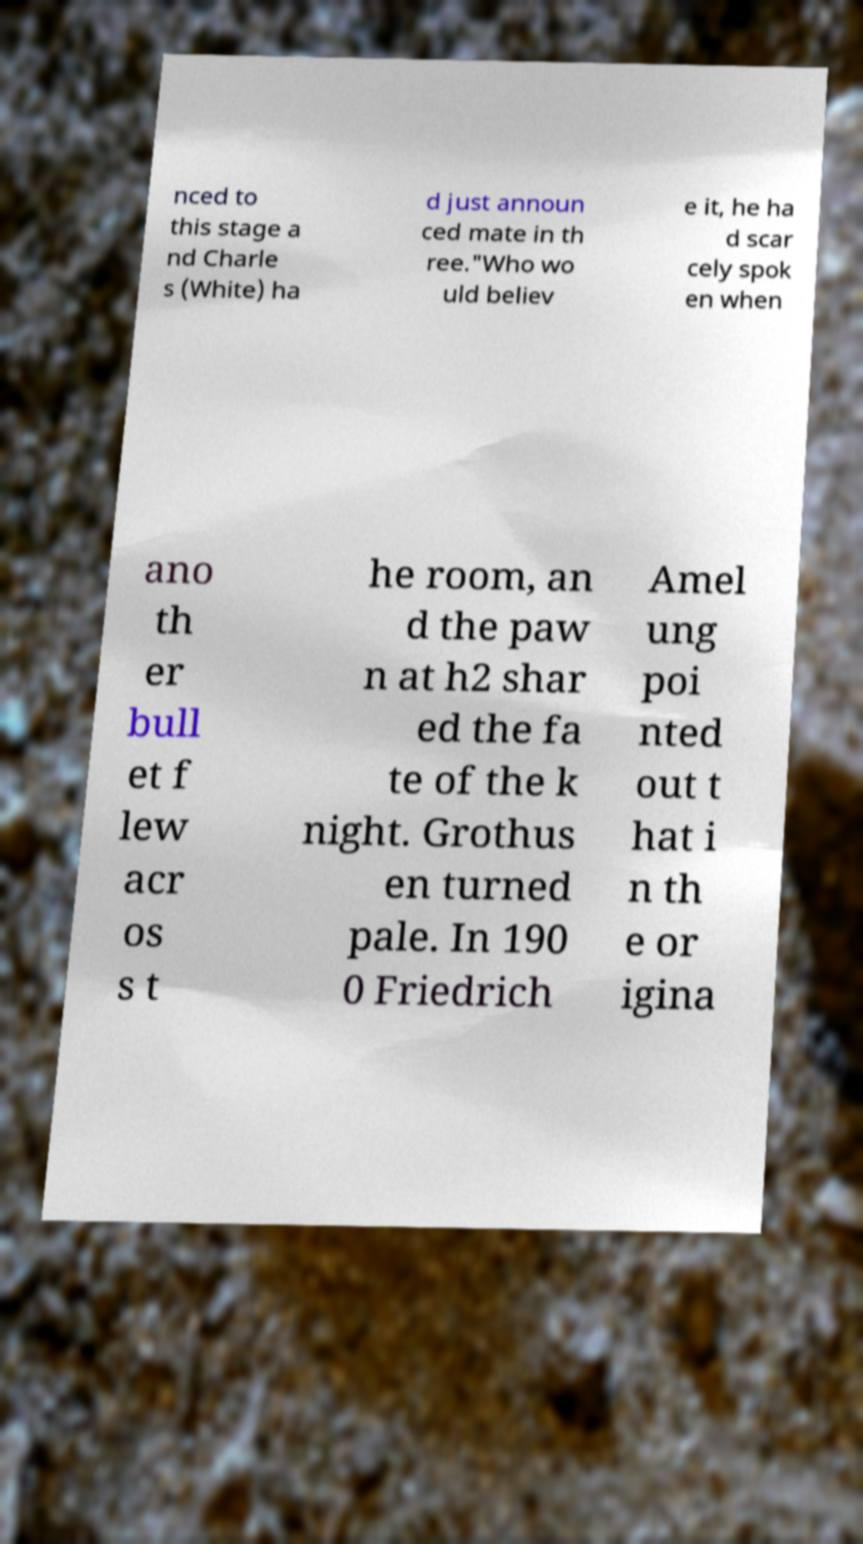What messages or text are displayed in this image? I need them in a readable, typed format. nced to this stage a nd Charle s (White) ha d just announ ced mate in th ree."Who wo uld believ e it, he ha d scar cely spok en when ano th er bull et f lew acr os s t he room, an d the paw n at h2 shar ed the fa te of the k night. Grothus en turned pale. In 190 0 Friedrich Amel ung poi nted out t hat i n th e or igina 